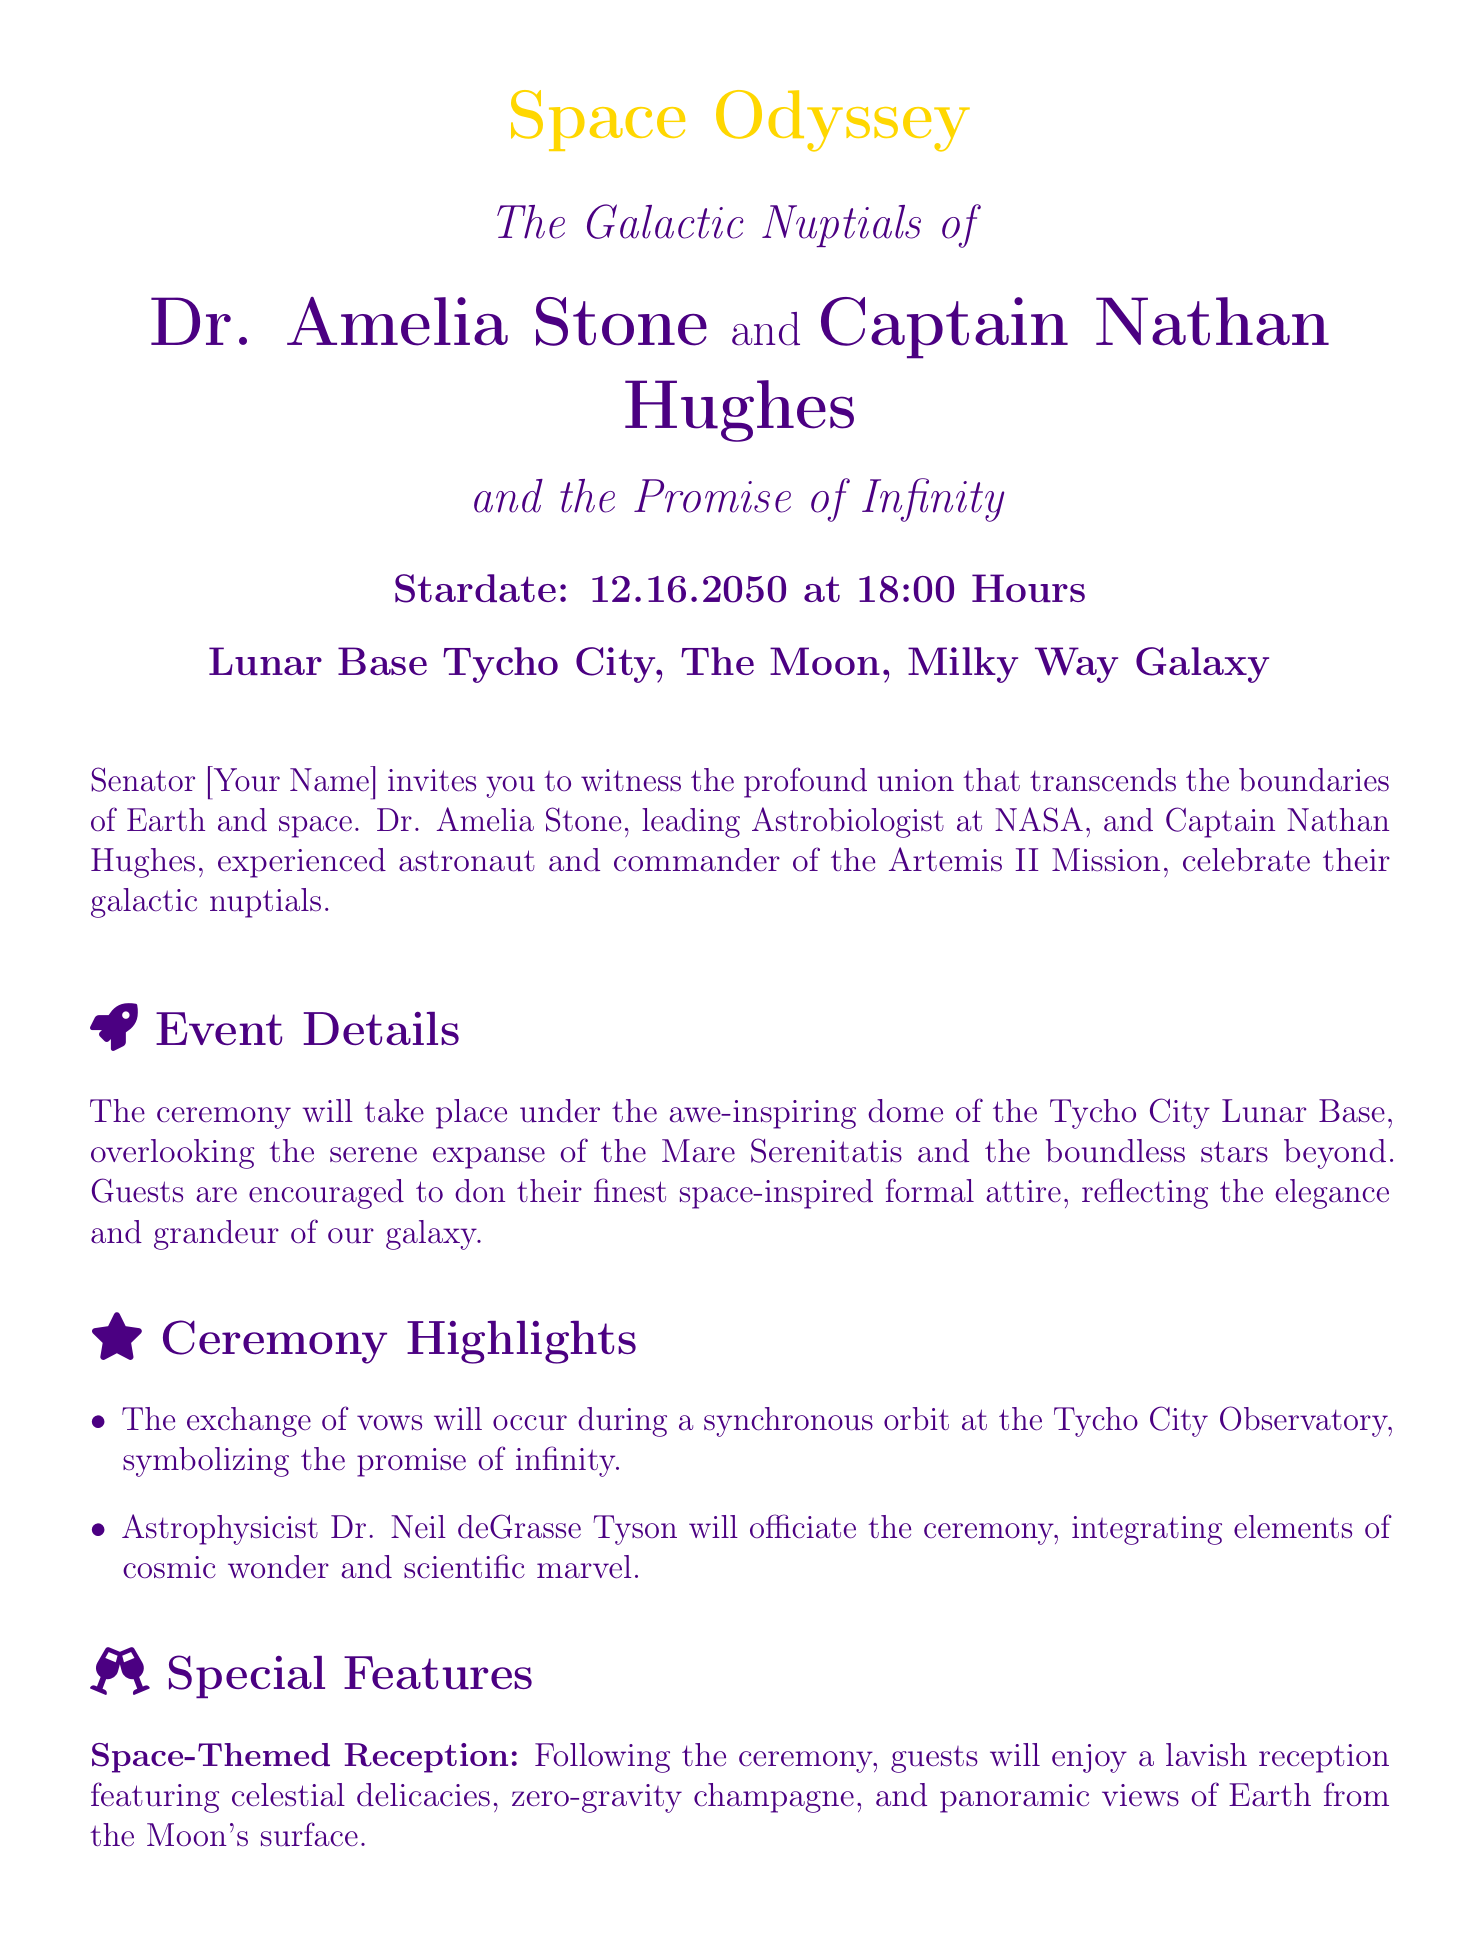What is the stardate of the wedding? The stardate is explicitly stated in the document as 12.16.2050.
Answer: 12.16.2050 Who is the officiant of the ceremony? The document mentions that Dr. Neil deGrasse Tyson will officiate the ceremony.
Answer: Dr. Neil deGrasse Tyson What is the venue of the ceremony? The ceremony will take place at Lunar Base Tycho City.
Answer: Lunar Base Tycho City What time should guests arrive at the Kennedy Space Center? Guests are requested to arrive by 14:00 hours for a timely launch.
Answer: 14:00 hours What is the dress code for the guests? The invitation encourages guests to don space-inspired formal attire.
Answer: Space-inspired formal attire How will the vows be exchanged? The vows will be exchanged during a synchronous orbit at the Tycho City Observatory.
Answer: Synchronous orbit What will be served at the reception? The reception will feature celestial delicacies and zero-gravity champagne.
Answer: Celestial delicacies, zero-gravity champagne What is the theme of the orchestral performance? The performance will be a tribute to '2001: A Space Odyssey.'
Answer: '2001: A Space Odyssey' 